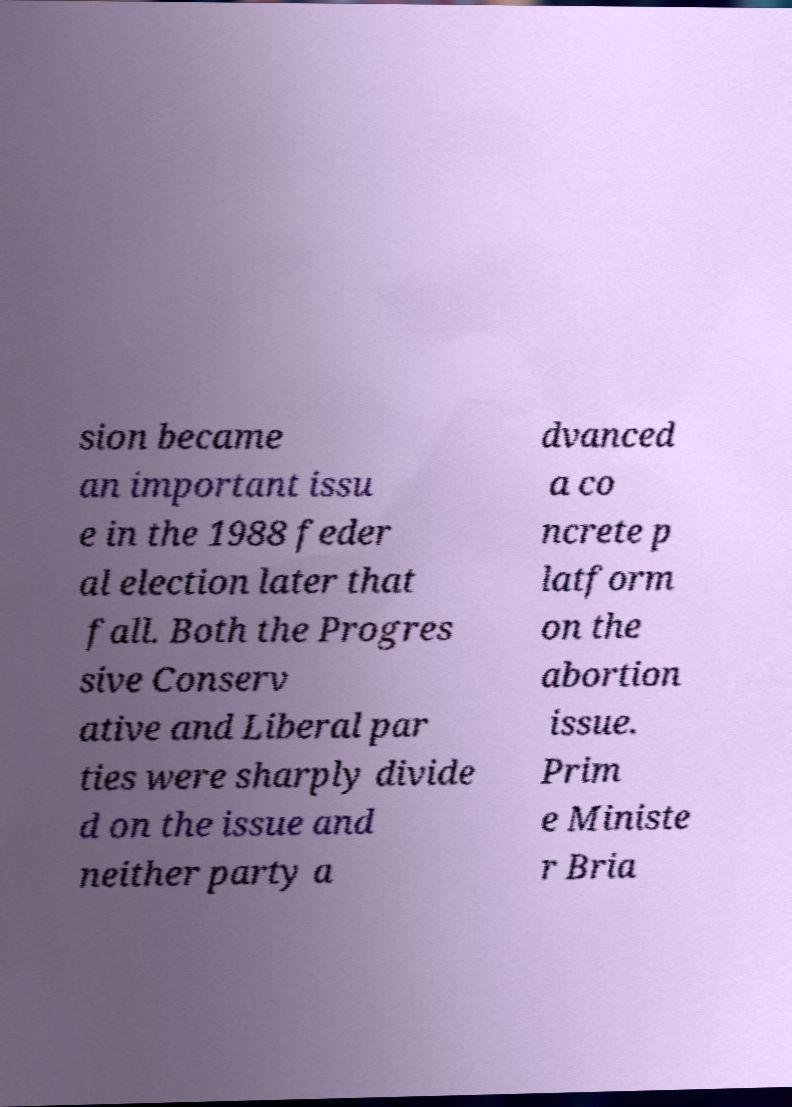There's text embedded in this image that I need extracted. Can you transcribe it verbatim? sion became an important issu e in the 1988 feder al election later that fall. Both the Progres sive Conserv ative and Liberal par ties were sharply divide d on the issue and neither party a dvanced a co ncrete p latform on the abortion issue. Prim e Ministe r Bria 